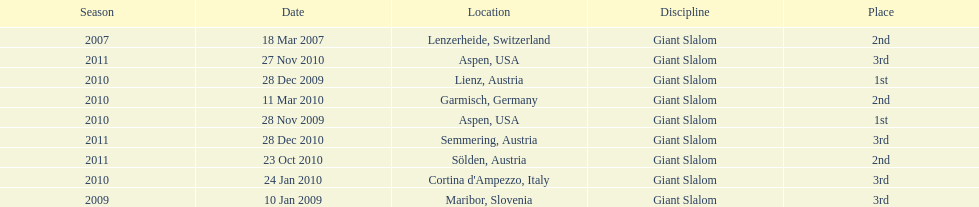What is the total number of her 2nd place finishes on the list? 3. 